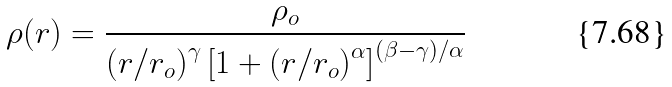<formula> <loc_0><loc_0><loc_500><loc_500>\rho ( r ) = \frac { \rho _ { o } } { \left ( r / r _ { o } \right ) ^ { \gamma } \left [ 1 + \left ( r / r _ { o } \right ) ^ { \alpha } \right ] ^ { ( { \beta - \gamma } ) / \alpha } }</formula> 